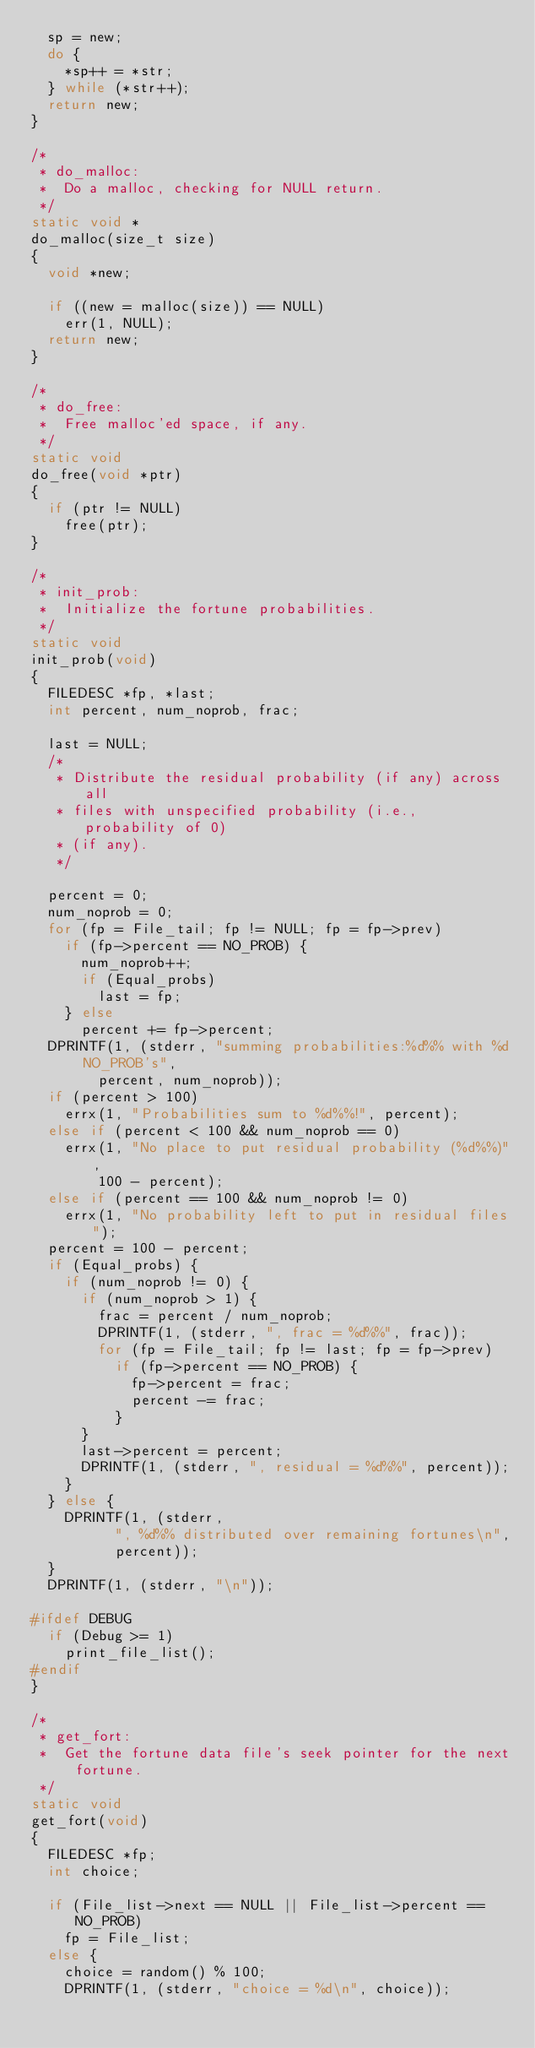<code> <loc_0><loc_0><loc_500><loc_500><_C_>	sp = new;
	do {
		*sp++ = *str;
	} while (*str++);
	return new;
}

/*
 * do_malloc:
 *	Do a malloc, checking for NULL return.
 */
static void *
do_malloc(size_t size)
{
	void *new;

	if ((new = malloc(size)) == NULL)
		err(1, NULL);
	return new;
}

/*
 * do_free:
 *	Free malloc'ed space, if any.
 */
static void
do_free(void *ptr)
{
	if (ptr != NULL)
		free(ptr);
}

/*
 * init_prob:
 *	Initialize the fortune probabilities.
 */
static void
init_prob(void)
{
	FILEDESC *fp, *last;
	int percent, num_noprob, frac;

	last = NULL;
	/*
	 * Distribute the residual probability (if any) across all
	 * files with unspecified probability (i.e., probability of 0)
	 * (if any).
	 */

	percent = 0;
	num_noprob = 0;
	for (fp = File_tail; fp != NULL; fp = fp->prev)
		if (fp->percent == NO_PROB) {
			num_noprob++;
			if (Equal_probs)
				last = fp;
		} else
			percent += fp->percent;
	DPRINTF(1, (stderr, "summing probabilities:%d%% with %d NO_PROB's",
		    percent, num_noprob));
	if (percent > 100)
		errx(1, "Probabilities sum to %d%%!", percent);
	else if (percent < 100 && num_noprob == 0)
		errx(1, "No place to put residual probability (%d%%)",
		    100 - percent);
	else if (percent == 100 && num_noprob != 0)
		errx(1, "No probability left to put in residual files");
	percent = 100 - percent;
	if (Equal_probs) {
		if (num_noprob != 0) {
			if (num_noprob > 1) {
				frac = percent / num_noprob;
				DPRINTF(1, (stderr, ", frac = %d%%", frac));
				for (fp = File_tail; fp != last; fp = fp->prev)
					if (fp->percent == NO_PROB) {
						fp->percent = frac;
						percent -= frac;
					}
			}
			last->percent = percent;
			DPRINTF(1, (stderr, ", residual = %d%%", percent));
		}
	} else {
		DPRINTF(1, (stderr,
			    ", %d%% distributed over remaining fortunes\n",
			    percent));
	}
	DPRINTF(1, (stderr, "\n"));

#ifdef DEBUG
	if (Debug >= 1)
		print_file_list();
#endif
}

/*
 * get_fort:
 *	Get the fortune data file's seek pointer for the next fortune.
 */
static void
get_fort(void)
{
	FILEDESC *fp;
	int choice;

	if (File_list->next == NULL || File_list->percent == NO_PROB)
		fp = File_list;
	else {
		choice = random() % 100;
		DPRINTF(1, (stderr, "choice = %d\n", choice));</code> 